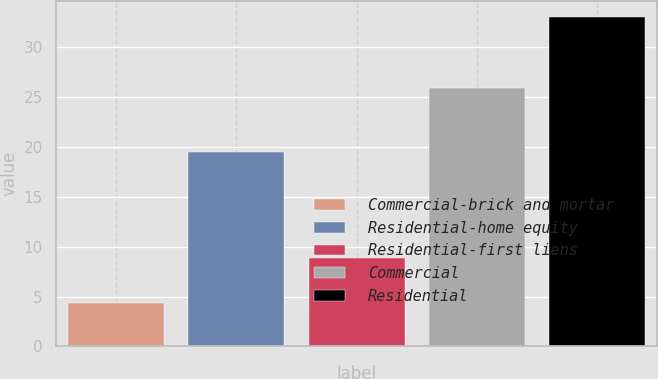<chart> <loc_0><loc_0><loc_500><loc_500><bar_chart><fcel>Commercial-brick and mortar<fcel>Residential-home equity<fcel>Residential-first liens<fcel>Commercial<fcel>Residential<nl><fcel>4.4<fcel>19.5<fcel>8.9<fcel>25.9<fcel>33<nl></chart> 